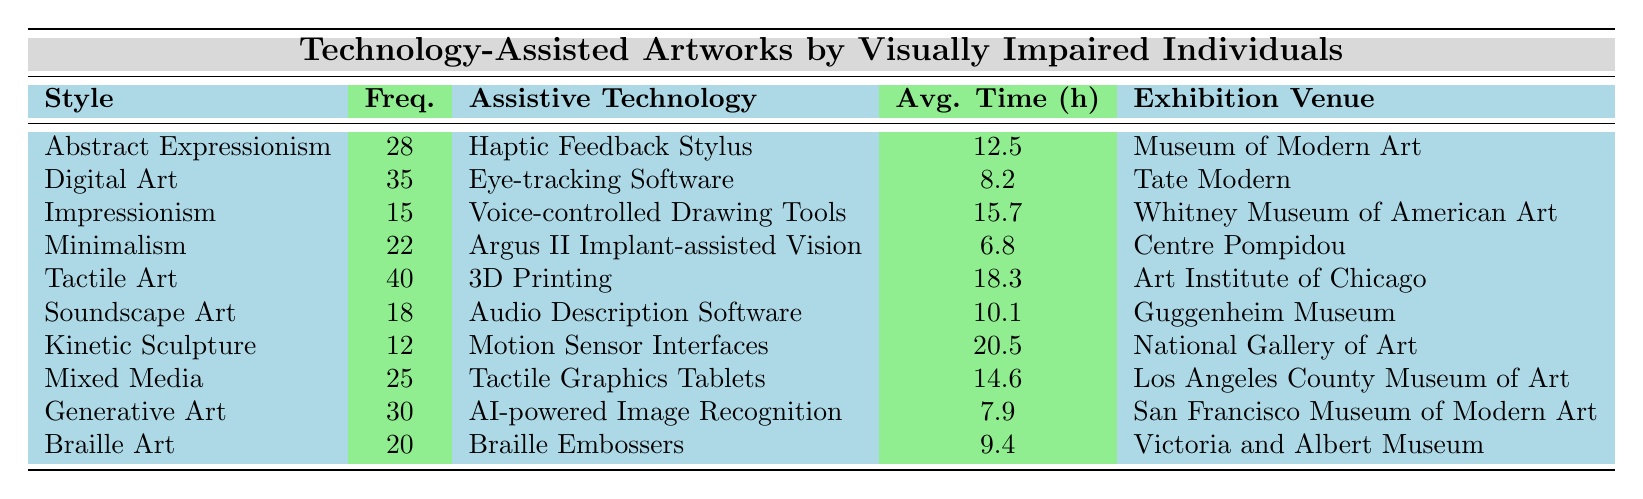What is the most frequently represented artistic style in the table? The highest frequency value listed in the table is for "Tactile Art," with a frequency of 40.
Answer: Tactile Art Which assistive technology is used for Mixed Media artworks? In the table, Mixed Media is paired with "Tactile Graphics Tablets" as its assistive technology.
Answer: Tactile Graphics Tablets How many artistic styles have a frequency of 20 or less? The styles with frequency of 20 or less are "Impressionism" (15), "Kinetic Sculpture" (12), which totals to 2 artistic styles.
Answer: 2 Is there an artistic style that takes longer than 15 hours on average to complete? Yes, "Tactile Art" takes an average of 18.3 hours, which is longer than 15 hours.
Answer: Yes What is the average completion time for the top three artistic styles based on frequency? The top three styles are "Tactile Art" (18.3), "Digital Art" (8.2), and "Abstract Expressionism" (12.5). Their average is (18.3 + 8.2 + 12.5) / 3 = 13.33 hours.
Answer: 13.33 Which exhibition venue is associated with Soundscape Art? According to the table, "Soundscape Art" is associated with the "Guggenheim Museum."
Answer: Guggenheim Museum What is the frequency of Braille Art? The frequency value for "Braille Art" listed in the table is 20.
Answer: 20 If we sum the frequency of Impressionism and Kinetic Sculpture, what do we get? The frequency for "Impressionism" is 15 and for "Kinetic Sculpture" is 12. Adding these gives 15 + 12 = 27.
Answer: 27 Which assistive technology has the least average completion time? The assistive technology with the least average completion time is "Minimalism," which takes 6.8 hours.
Answer: Minimalism Are there any artistic styles that share the same exhibition venue? No, each artistic style is paired with a unique exhibition venue in the table, no repeats are present.
Answer: No 